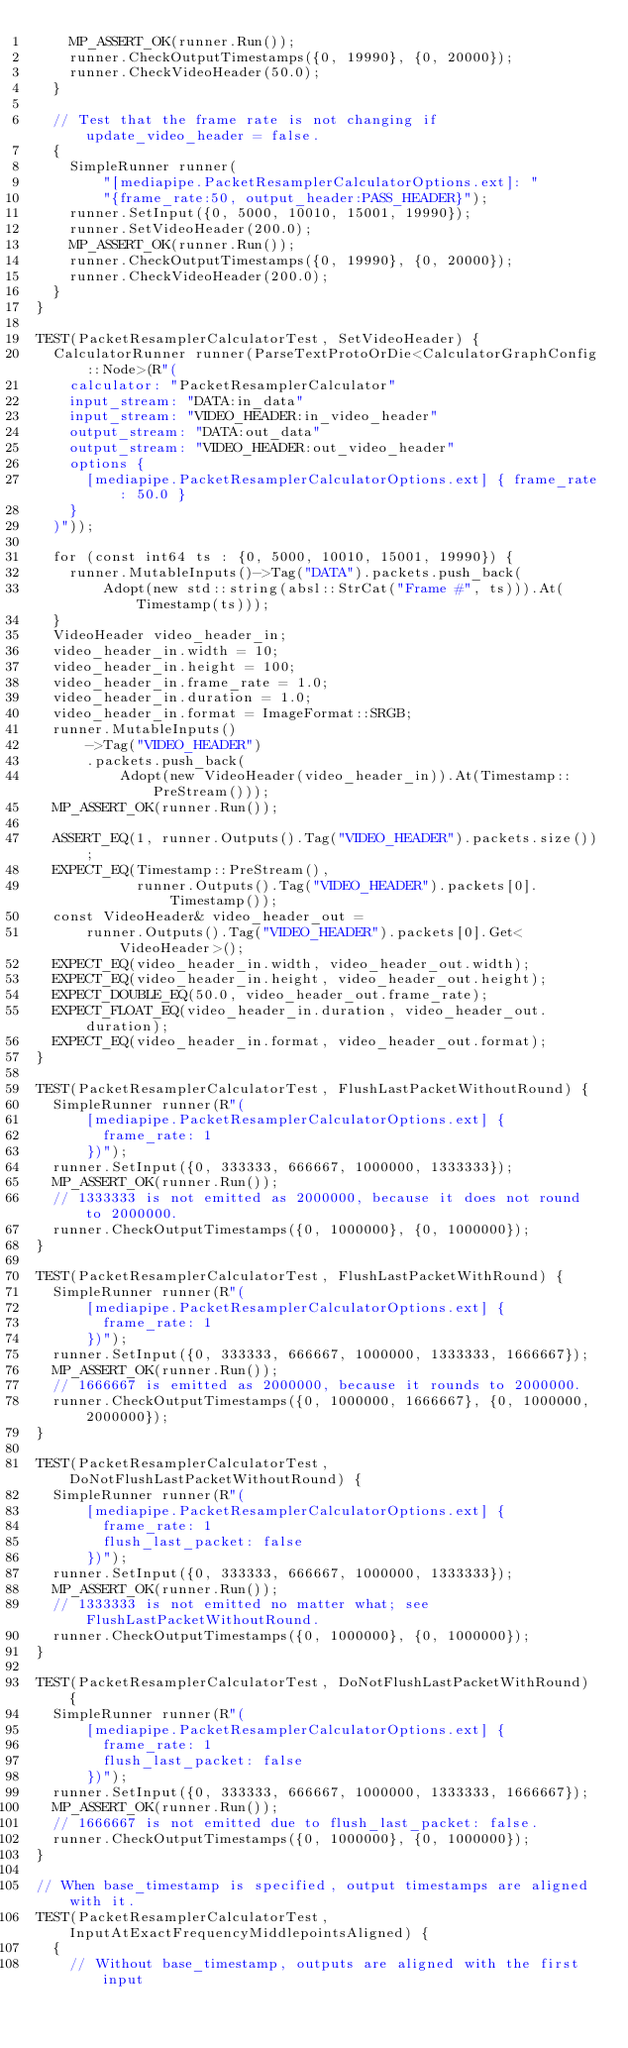<code> <loc_0><loc_0><loc_500><loc_500><_C++_>    MP_ASSERT_OK(runner.Run());
    runner.CheckOutputTimestamps({0, 19990}, {0, 20000});
    runner.CheckVideoHeader(50.0);
  }

  // Test that the frame rate is not changing if update_video_header = false.
  {
    SimpleRunner runner(
        "[mediapipe.PacketResamplerCalculatorOptions.ext]: "
        "{frame_rate:50, output_header:PASS_HEADER}");
    runner.SetInput({0, 5000, 10010, 15001, 19990});
    runner.SetVideoHeader(200.0);
    MP_ASSERT_OK(runner.Run());
    runner.CheckOutputTimestamps({0, 19990}, {0, 20000});
    runner.CheckVideoHeader(200.0);
  }
}

TEST(PacketResamplerCalculatorTest, SetVideoHeader) {
  CalculatorRunner runner(ParseTextProtoOrDie<CalculatorGraphConfig::Node>(R"(
    calculator: "PacketResamplerCalculator"
    input_stream: "DATA:in_data"
    input_stream: "VIDEO_HEADER:in_video_header"
    output_stream: "DATA:out_data"
    output_stream: "VIDEO_HEADER:out_video_header"
    options {
      [mediapipe.PacketResamplerCalculatorOptions.ext] { frame_rate: 50.0 }
    }
  )"));

  for (const int64 ts : {0, 5000, 10010, 15001, 19990}) {
    runner.MutableInputs()->Tag("DATA").packets.push_back(
        Adopt(new std::string(absl::StrCat("Frame #", ts))).At(Timestamp(ts)));
  }
  VideoHeader video_header_in;
  video_header_in.width = 10;
  video_header_in.height = 100;
  video_header_in.frame_rate = 1.0;
  video_header_in.duration = 1.0;
  video_header_in.format = ImageFormat::SRGB;
  runner.MutableInputs()
      ->Tag("VIDEO_HEADER")
      .packets.push_back(
          Adopt(new VideoHeader(video_header_in)).At(Timestamp::PreStream()));
  MP_ASSERT_OK(runner.Run());

  ASSERT_EQ(1, runner.Outputs().Tag("VIDEO_HEADER").packets.size());
  EXPECT_EQ(Timestamp::PreStream(),
            runner.Outputs().Tag("VIDEO_HEADER").packets[0].Timestamp());
  const VideoHeader& video_header_out =
      runner.Outputs().Tag("VIDEO_HEADER").packets[0].Get<VideoHeader>();
  EXPECT_EQ(video_header_in.width, video_header_out.width);
  EXPECT_EQ(video_header_in.height, video_header_out.height);
  EXPECT_DOUBLE_EQ(50.0, video_header_out.frame_rate);
  EXPECT_FLOAT_EQ(video_header_in.duration, video_header_out.duration);
  EXPECT_EQ(video_header_in.format, video_header_out.format);
}

TEST(PacketResamplerCalculatorTest, FlushLastPacketWithoutRound) {
  SimpleRunner runner(R"(
      [mediapipe.PacketResamplerCalculatorOptions.ext] {
        frame_rate: 1
      })");
  runner.SetInput({0, 333333, 666667, 1000000, 1333333});
  MP_ASSERT_OK(runner.Run());
  // 1333333 is not emitted as 2000000, because it does not round to 2000000.
  runner.CheckOutputTimestamps({0, 1000000}, {0, 1000000});
}

TEST(PacketResamplerCalculatorTest, FlushLastPacketWithRound) {
  SimpleRunner runner(R"(
      [mediapipe.PacketResamplerCalculatorOptions.ext] {
        frame_rate: 1
      })");
  runner.SetInput({0, 333333, 666667, 1000000, 1333333, 1666667});
  MP_ASSERT_OK(runner.Run());
  // 1666667 is emitted as 2000000, because it rounds to 2000000.
  runner.CheckOutputTimestamps({0, 1000000, 1666667}, {0, 1000000, 2000000});
}

TEST(PacketResamplerCalculatorTest, DoNotFlushLastPacketWithoutRound) {
  SimpleRunner runner(R"(
      [mediapipe.PacketResamplerCalculatorOptions.ext] {
        frame_rate: 1
        flush_last_packet: false
      })");
  runner.SetInput({0, 333333, 666667, 1000000, 1333333});
  MP_ASSERT_OK(runner.Run());
  // 1333333 is not emitted no matter what; see FlushLastPacketWithoutRound.
  runner.CheckOutputTimestamps({0, 1000000}, {0, 1000000});
}

TEST(PacketResamplerCalculatorTest, DoNotFlushLastPacketWithRound) {
  SimpleRunner runner(R"(
      [mediapipe.PacketResamplerCalculatorOptions.ext] {
        frame_rate: 1
        flush_last_packet: false
      })");
  runner.SetInput({0, 333333, 666667, 1000000, 1333333, 1666667});
  MP_ASSERT_OK(runner.Run());
  // 1666667 is not emitted due to flush_last_packet: false.
  runner.CheckOutputTimestamps({0, 1000000}, {0, 1000000});
}

// When base_timestamp is specified, output timestamps are aligned with it.
TEST(PacketResamplerCalculatorTest, InputAtExactFrequencyMiddlepointsAligned) {
  {
    // Without base_timestamp, outputs are aligned with the first input</code> 